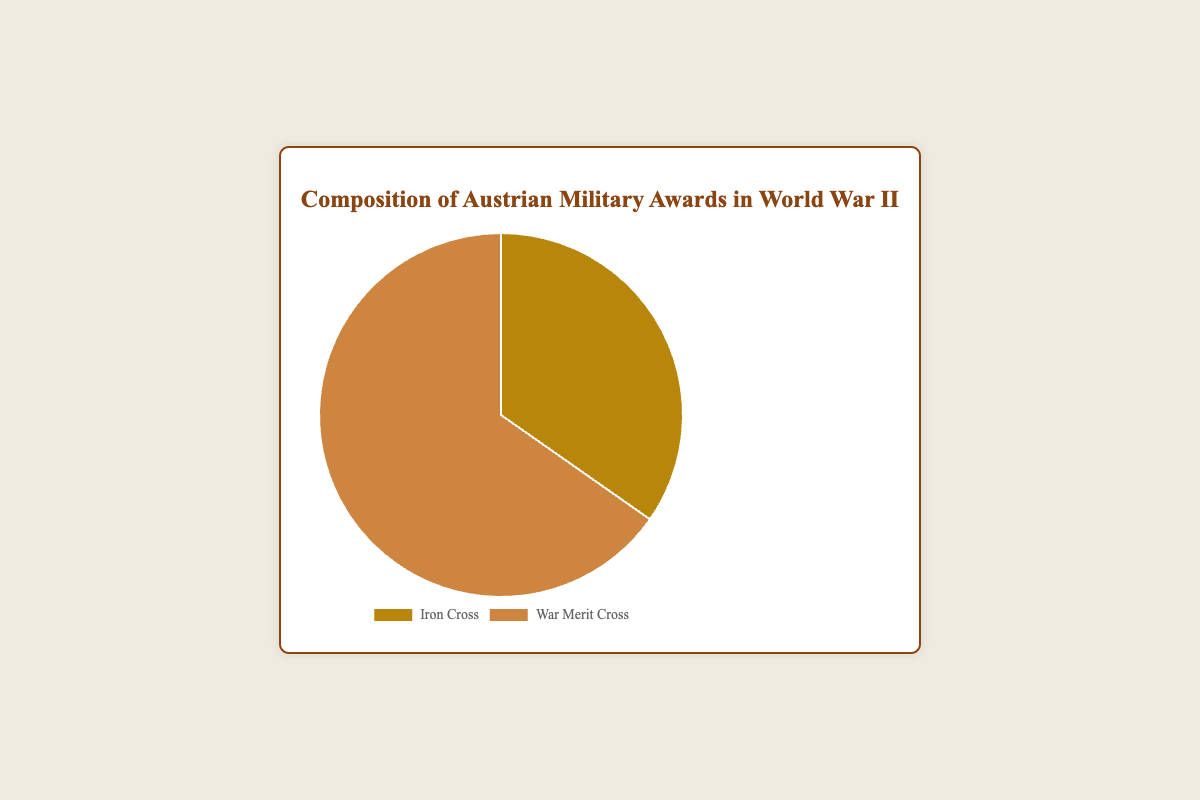what is the total number of Austrian military awards represented in the chart? To find the total number of awards, sum the counts of Iron Cross and War Merit Cross. That is 2500 (Iron Cross) + 4700 (War Merit Cross) = 7200
Answer: 7200 Which award was given more frequently, the Iron Cross or the War Merit Cross? Compare the counts of the two awards. The War Merit Cross was given to 4700 individuals, while the Iron Cross was given to 2500 individuals. Since 4700 is greater than 2500, the War Merit Cross was given more frequently.
Answer: War Merit Cross How many more War Merit Crosses were awarded compared to Iron Crosses? To find the difference in the number of awards, subtract the count of the Iron Cross from the count of the War Merit Cross. 4700 (War Merit Cross) - 2500 (Iron Cross) = 2200
Answer: 2200 What proportion of the total awards were Iron Crosses? To find the proportion, divide the number of Iron Crosses by the total number of awards. 2500 / 7200 ≈ 0.3472, or approximately 34.72%
Answer: Approximately 34.72% Which color on the chart represents the Iron Cross? According to the data provided, the Iron Cross is represented by a color, specifically '#b8860b' which is described as gold or dark goldenrod in the visual.
Answer: Gold What is the percentage of War Merit Crosses out of the total awards? To find the percentage, divide the number of War Merit Crosses by the total number of awards and multiply by 100. (4700 / 7200) * 100 ≈ 65.28%
Answer: Approximately 65.28% If another 500 Iron Crosses were awarded, what would the new total become? Add 500 to the initial count of Iron Crosses. 2500 + 500 = 3000. Then, sum the new number of Iron Crosses and the War Merit Crosses. 3000 + 4700 = 7700
Answer: 7700 What fraction of the awards are represented by the War Merit Cross? Divide the count of War Merit Crosses by the total number of awards to find the fraction. 4700 / 7200 = 47/72
Answer: 47/72 